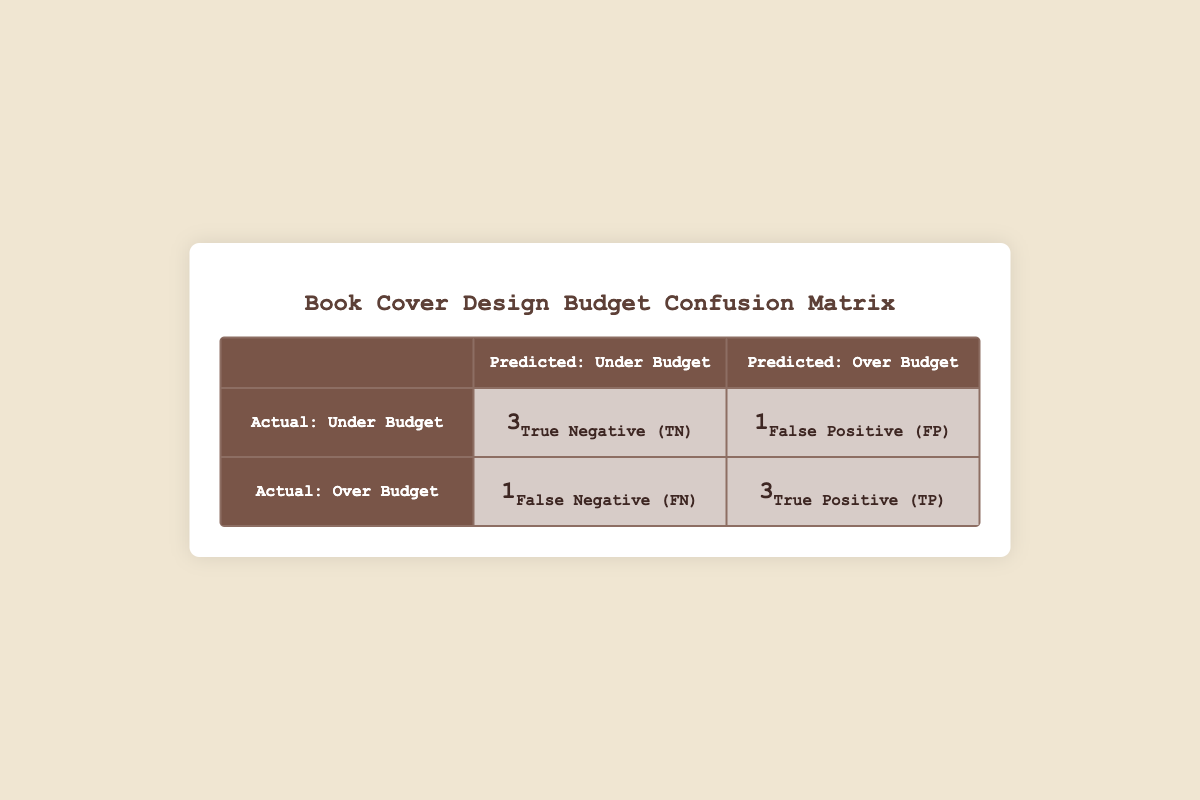What is the number of True Positives (TP)? The table indicates that the True Positives (TP) value is listed as 3 in the matrix section.
Answer: 3 What is the total number of projects that were under budget according to actual expenses? The True Negatives (TN) indicate 3 projects were correctly predicted to be under budget. The actual expenses for two other projects (The Forgotten Forest and Mystery at Ravenwood) were also under budget, but they are counted in the TN. So, 3 under budget projects were accurately identified.
Answer: 3 How many projects were predicted to be over budget but were actually under budget? This is indicated by the False Positive (FP) which is 1, meaning one project was predicted to exceed the budget but did not.
Answer: 1 What is the percentage of projects that are True Negatives (TN) out of the total number of projects? There are 8 total projects. The True Negatives (TN) are 3. To find the percentage, (3/8) * 100 = 37.5%.
Answer: 37.5% Was there any project that was over budget in both predictions and actual expenses? Looking at the values, only the project "Adventures in Elvish Lands" was over budget in both predicted (260) and actual (300) expenses, making the statement true.
Answer: Yes 